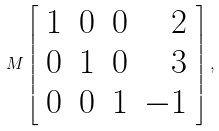Convert formula to latex. <formula><loc_0><loc_0><loc_500><loc_500>M \left [ { \begin{array} { r r r r } { 1 } & { 0 } & { 0 } & { 2 } \\ { 0 } & { 1 } & { 0 } & { 3 } \\ { 0 } & { 0 } & { 1 } & { - 1 } \end{array} } \right ] ,</formula> 